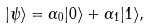Convert formula to latex. <formula><loc_0><loc_0><loc_500><loc_500>| \psi \rangle = \alpha _ { 0 } | 0 \rangle + \alpha _ { 1 } | 1 \rangle ,</formula> 